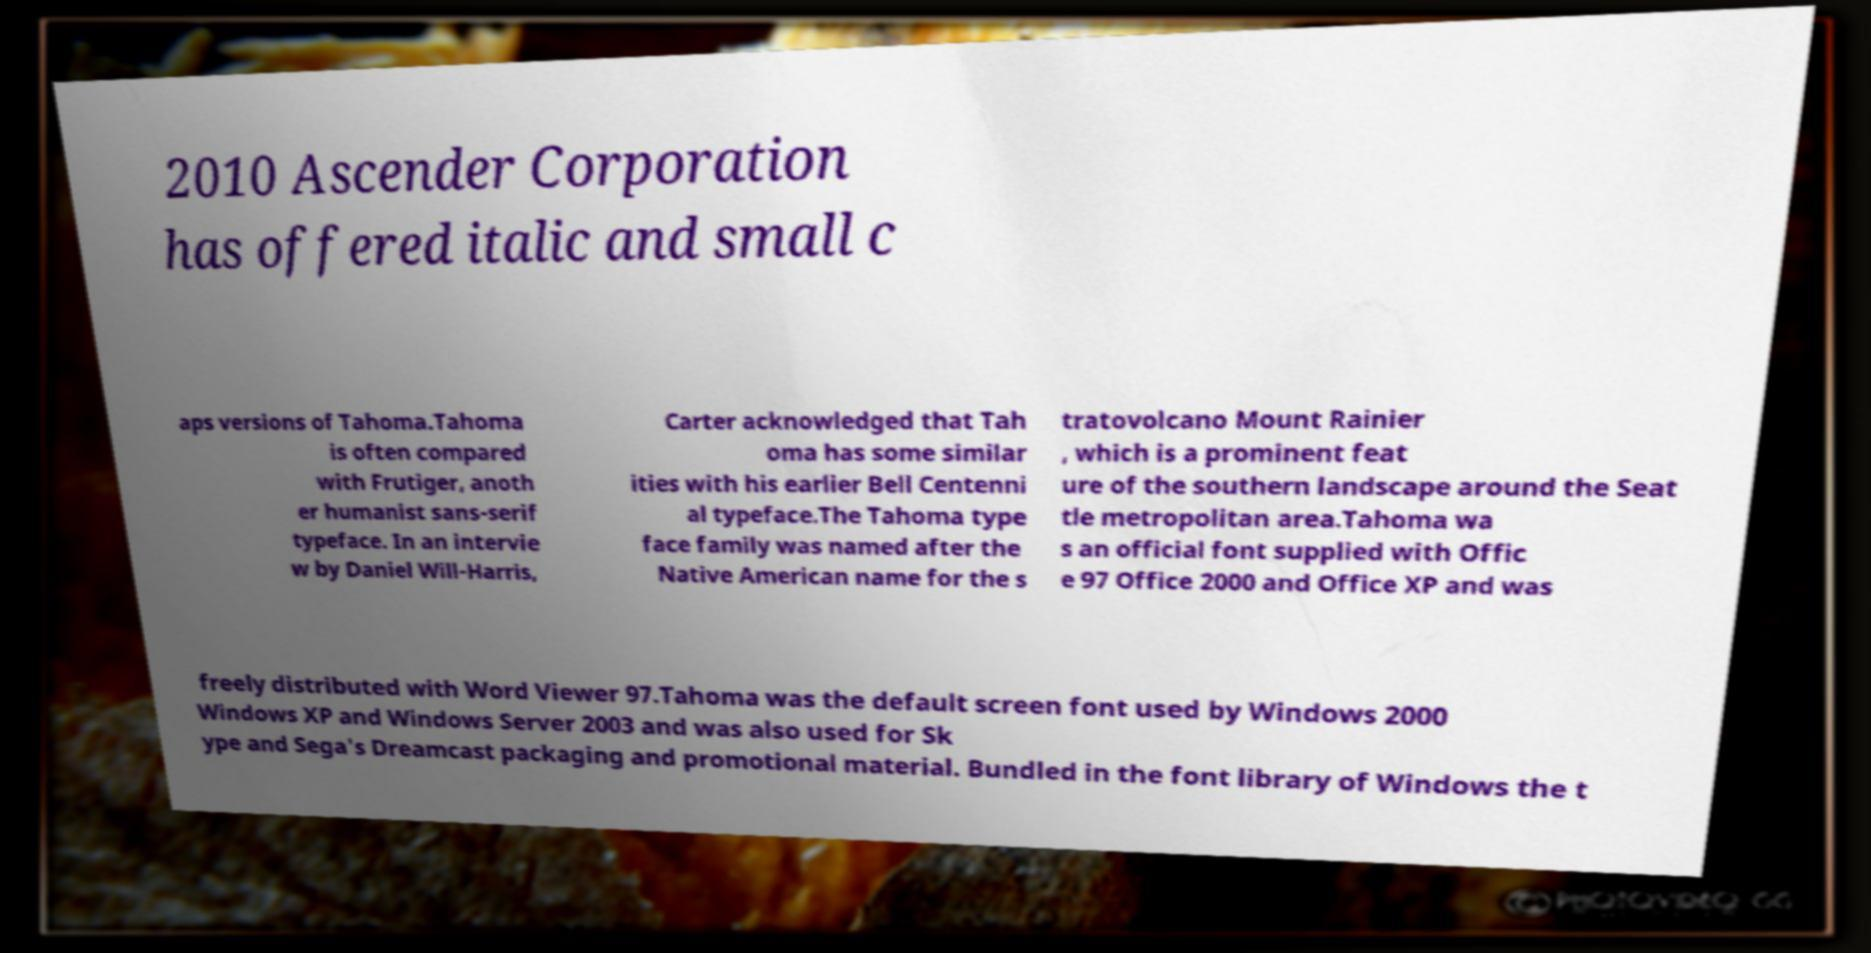There's text embedded in this image that I need extracted. Can you transcribe it verbatim? 2010 Ascender Corporation has offered italic and small c aps versions of Tahoma.Tahoma is often compared with Frutiger, anoth er humanist sans-serif typeface. In an intervie w by Daniel Will-Harris, Carter acknowledged that Tah oma has some similar ities with his earlier Bell Centenni al typeface.The Tahoma type face family was named after the Native American name for the s tratovolcano Mount Rainier , which is a prominent feat ure of the southern landscape around the Seat tle metropolitan area.Tahoma wa s an official font supplied with Offic e 97 Office 2000 and Office XP and was freely distributed with Word Viewer 97.Tahoma was the default screen font used by Windows 2000 Windows XP and Windows Server 2003 and was also used for Sk ype and Sega's Dreamcast packaging and promotional material. Bundled in the font library of Windows the t 